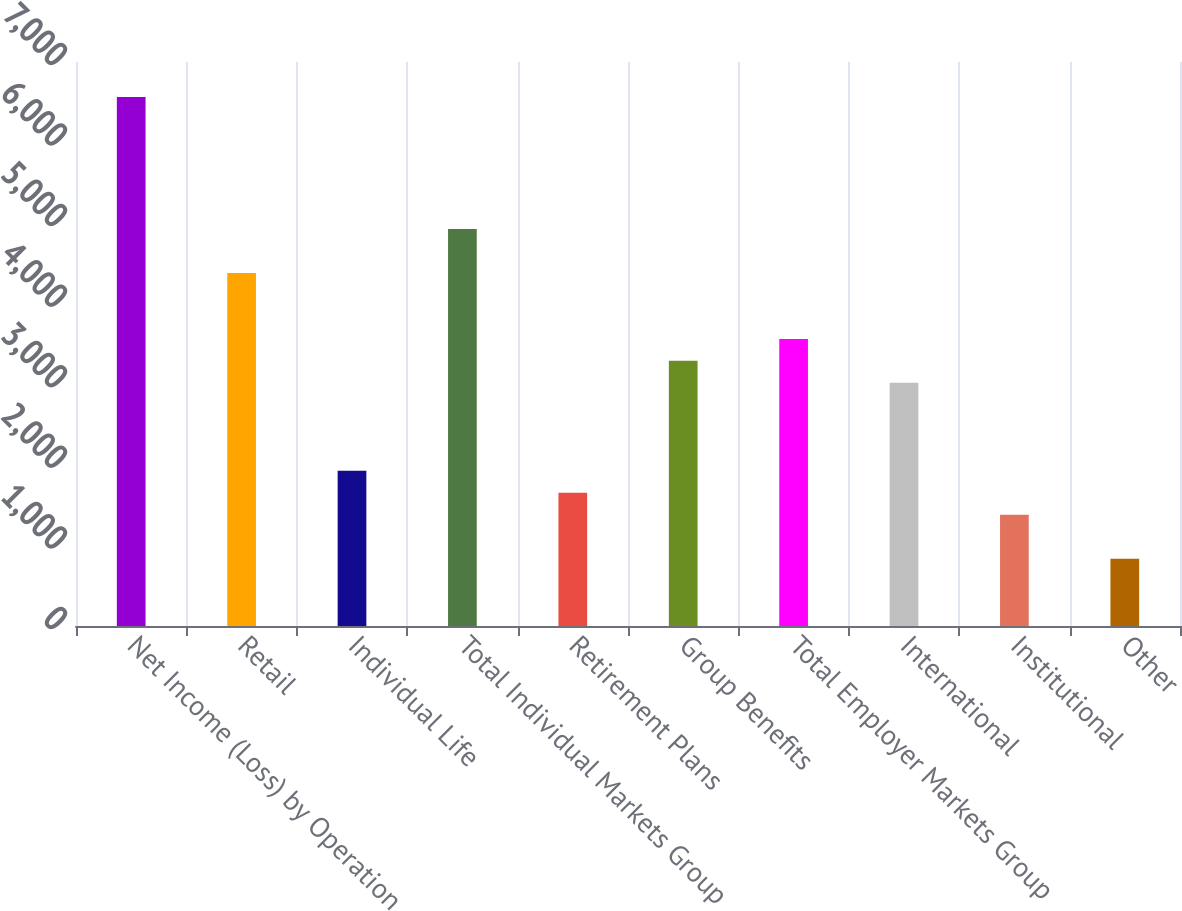Convert chart. <chart><loc_0><loc_0><loc_500><loc_500><bar_chart><fcel>Net Income (Loss) by Operation<fcel>Retail<fcel>Individual Life<fcel>Total Individual Markets Group<fcel>Retirement Plans<fcel>Group Benefits<fcel>Total Employer Markets Group<fcel>International<fcel>Institutional<fcel>Other<nl><fcel>6564.2<fcel>4381.8<fcel>1926.6<fcel>4927.4<fcel>1653.8<fcel>3290.6<fcel>3563.4<fcel>3017.8<fcel>1381<fcel>835.4<nl></chart> 